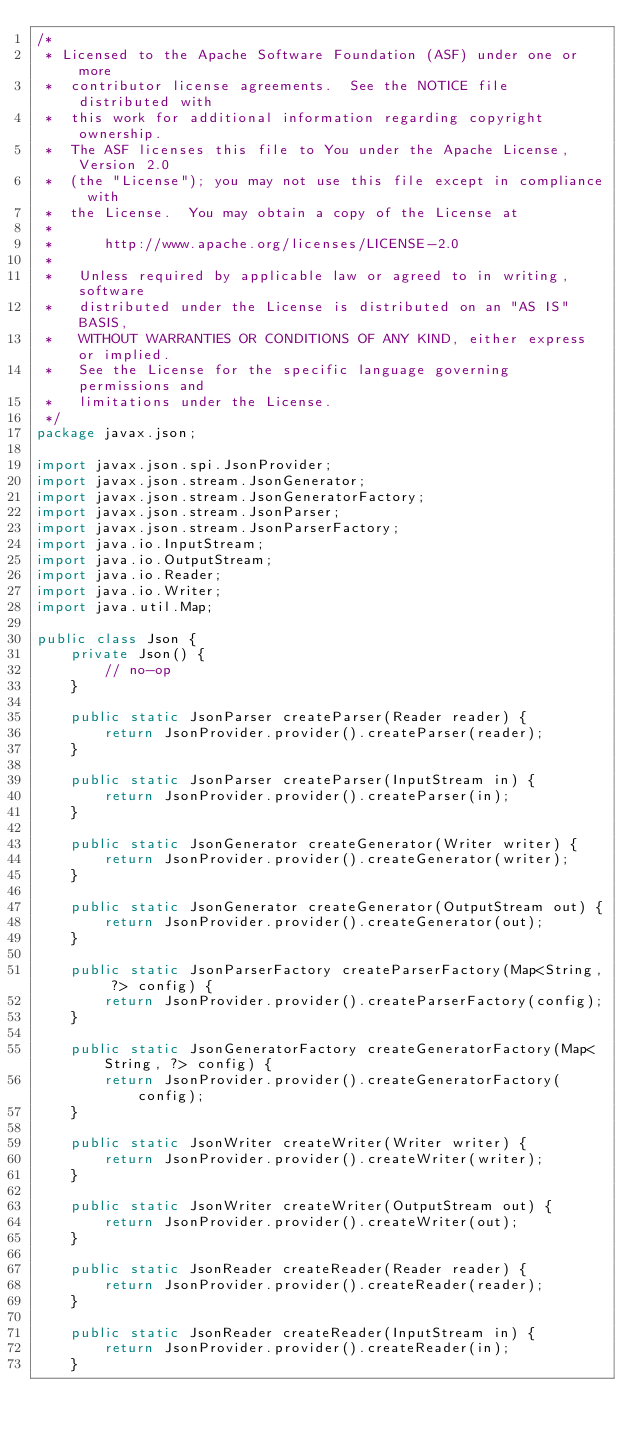<code> <loc_0><loc_0><loc_500><loc_500><_Java_>/*
 * Licensed to the Apache Software Foundation (ASF) under one or more
 *  contributor license agreements.  See the NOTICE file distributed with
 *  this work for additional information regarding copyright ownership.
 *  The ASF licenses this file to You under the Apache License, Version 2.0
 *  (the "License"); you may not use this file except in compliance with
 *  the License.  You may obtain a copy of the License at
 *
 *      http://www.apache.org/licenses/LICENSE-2.0
 *
 *   Unless required by applicable law or agreed to in writing, software
 *   distributed under the License is distributed on an "AS IS" BASIS,
 *   WITHOUT WARRANTIES OR CONDITIONS OF ANY KIND, either express or implied.
 *   See the License for the specific language governing permissions and
 *   limitations under the License.
 */
package javax.json;

import javax.json.spi.JsonProvider;
import javax.json.stream.JsonGenerator;
import javax.json.stream.JsonGeneratorFactory;
import javax.json.stream.JsonParser;
import javax.json.stream.JsonParserFactory;
import java.io.InputStream;
import java.io.OutputStream;
import java.io.Reader;
import java.io.Writer;
import java.util.Map;

public class Json {
    private Json() {
        // no-op
    }

    public static JsonParser createParser(Reader reader) {
        return JsonProvider.provider().createParser(reader);
    }

    public static JsonParser createParser(InputStream in) {
        return JsonProvider.provider().createParser(in);
    }

    public static JsonGenerator createGenerator(Writer writer) {
        return JsonProvider.provider().createGenerator(writer);
    }

    public static JsonGenerator createGenerator(OutputStream out) {
        return JsonProvider.provider().createGenerator(out);
    }

    public static JsonParserFactory createParserFactory(Map<String, ?> config) {
        return JsonProvider.provider().createParserFactory(config);
    }

    public static JsonGeneratorFactory createGeneratorFactory(Map<String, ?> config) {
        return JsonProvider.provider().createGeneratorFactory(config);
    }

    public static JsonWriter createWriter(Writer writer) {
        return JsonProvider.provider().createWriter(writer);
    }

    public static JsonWriter createWriter(OutputStream out) {
        return JsonProvider.provider().createWriter(out);
    }

    public static JsonReader createReader(Reader reader) {
        return JsonProvider.provider().createReader(reader);
    }

    public static JsonReader createReader(InputStream in) {
        return JsonProvider.provider().createReader(in);
    }
</code> 